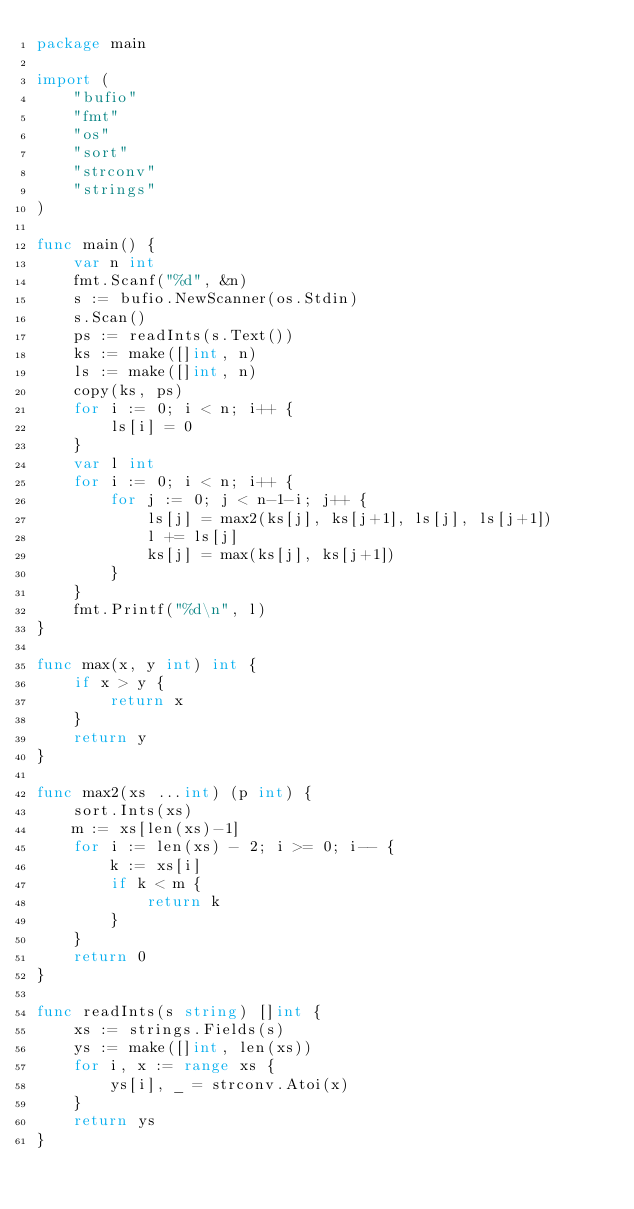Convert code to text. <code><loc_0><loc_0><loc_500><loc_500><_Go_>package main

import (
	"bufio"
	"fmt"
	"os"
	"sort"
	"strconv"
	"strings"
)

func main() {
	var n int
	fmt.Scanf("%d", &n)
	s := bufio.NewScanner(os.Stdin)
	s.Scan()
	ps := readInts(s.Text())
	ks := make([]int, n)
	ls := make([]int, n)
	copy(ks, ps)
	for i := 0; i < n; i++ {
		ls[i] = 0
	}
	var l int
	for i := 0; i < n; i++ {
		for j := 0; j < n-1-i; j++ {
			ls[j] = max2(ks[j], ks[j+1], ls[j], ls[j+1])
			l += ls[j]
			ks[j] = max(ks[j], ks[j+1])
		}
	}
	fmt.Printf("%d\n", l)
}

func max(x, y int) int {
	if x > y {
		return x
	}
	return y
}

func max2(xs ...int) (p int) {
	sort.Ints(xs)
	m := xs[len(xs)-1]
	for i := len(xs) - 2; i >= 0; i-- {
		k := xs[i]
		if k < m {
			return k
		}
	}
	return 0
}

func readInts(s string) []int {
	xs := strings.Fields(s)
	ys := make([]int, len(xs))
	for i, x := range xs {
		ys[i], _ = strconv.Atoi(x)
	}
	return ys
}
</code> 